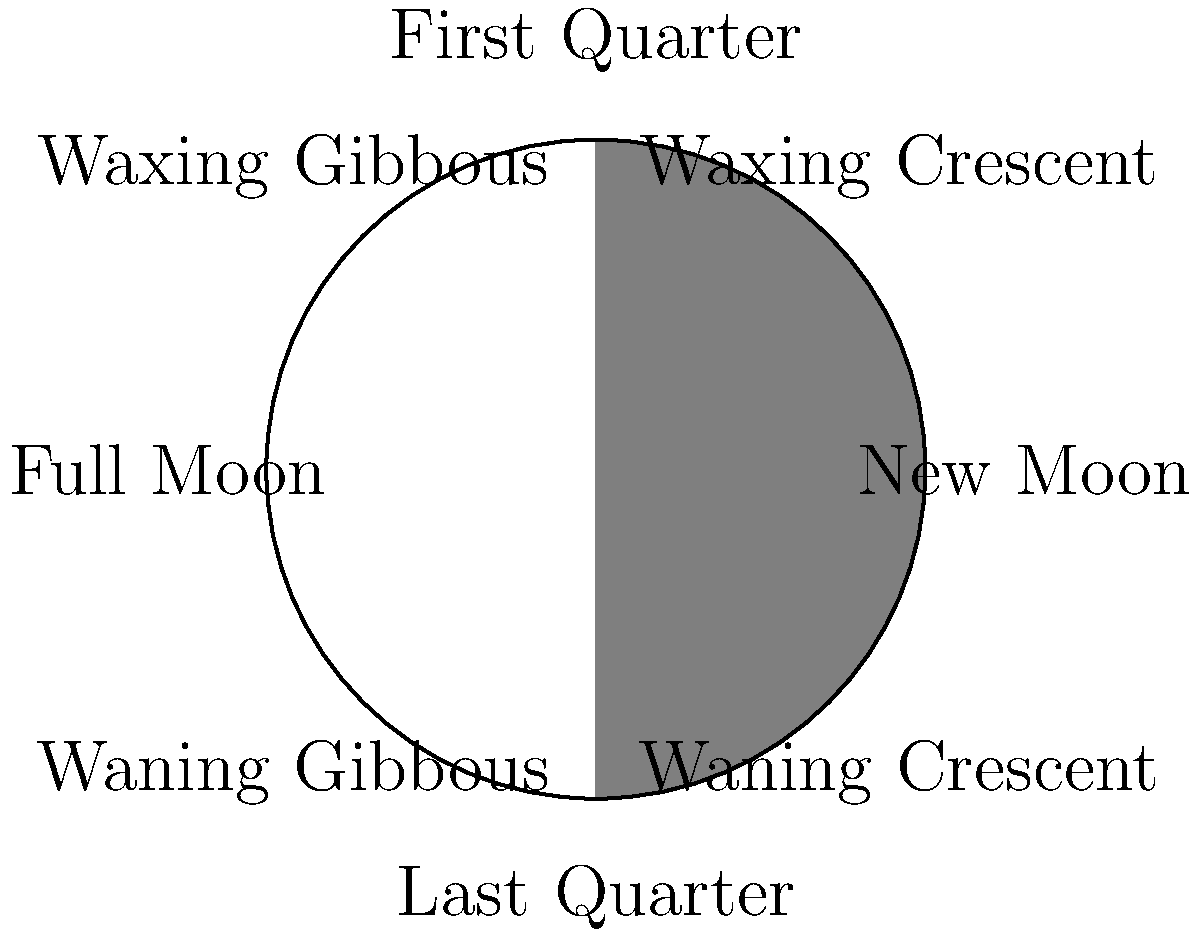As a hotel owner who has implemented sustainable practices, you're considering organizing a moonlight nature walk for your guests. Which phase of the Moon would be best for this activity, and how many days after the New Moon does this phase typically occur? To answer this question, let's consider the phases of the Moon and their characteristics:

1. New Moon: The Moon is not visible from Earth.
2. Waxing Crescent: A small sliver of the Moon is visible, increasing each night.
3. First Quarter: Half of the Moon's illuminated surface is visible.
4. Waxing Gibbous: More than half of the Moon is visible, but not yet full.
5. Full Moon: The entire illuminated surface of the Moon is visible from Earth.
6. Waning Gibbous: More than half of the Moon is visible, decreasing each night.
7. Last Quarter: Half of the Moon's illuminated surface is visible, opposite side from First Quarter.
8. Waning Crescent: A small sliver of the Moon is visible, decreasing each night.

For a moonlight nature walk, the Full Moon phase would be ideal as it provides the most illumination. This would allow guests to see the natural surroundings more clearly and create a memorable experience.

The lunar cycle, from one New Moon to the next, takes approximately 29.5 days. The Full Moon occurs roughly halfway through this cycle. Therefore, the Full Moon typically occurs about 14.75 days after the New Moon.

To be more precise:
$\text{Days until Full Moon} = \frac{29.5 \text{ days}}{2} = 14.75 \text{ days}$

Rounding to the nearest whole number, we can say that the Full Moon occurs approximately 15 days after the New Moon.
Answer: Full Moon, occurring approximately 15 days after the New Moon. 